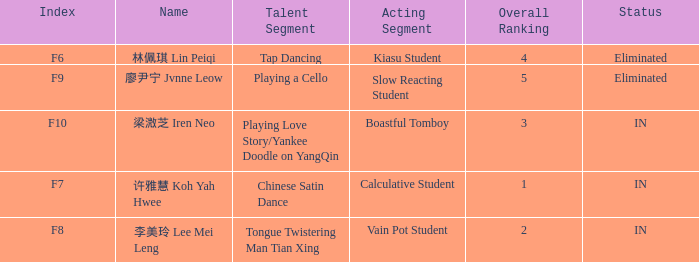What's the acting segment of 林佩琪 lin peiqi's events that are eliminated? Kiasu Student. Can you parse all the data within this table? {'header': ['Index', 'Name', 'Talent Segment', 'Acting Segment', 'Overall Ranking', 'Status'], 'rows': [['F6', '林佩琪 Lin Peiqi', 'Tap Dancing', 'Kiasu Student', '4', 'Eliminated'], ['F9', '廖尹宁 Jvnne Leow', 'Playing a Cello', 'Slow Reacting Student', '5', 'Eliminated'], ['F10', '梁溦芝 Iren Neo', 'Playing Love Story/Yankee Doodle on YangQin', 'Boastful Tomboy', '3', 'IN'], ['F7', '许雅慧 Koh Yah Hwee', 'Chinese Satin Dance', 'Calculative Student', '1', 'IN'], ['F8', '李美玲 Lee Mei Leng', 'Tongue Twistering Man Tian Xing', 'Vain Pot Student', '2', 'IN']]} 